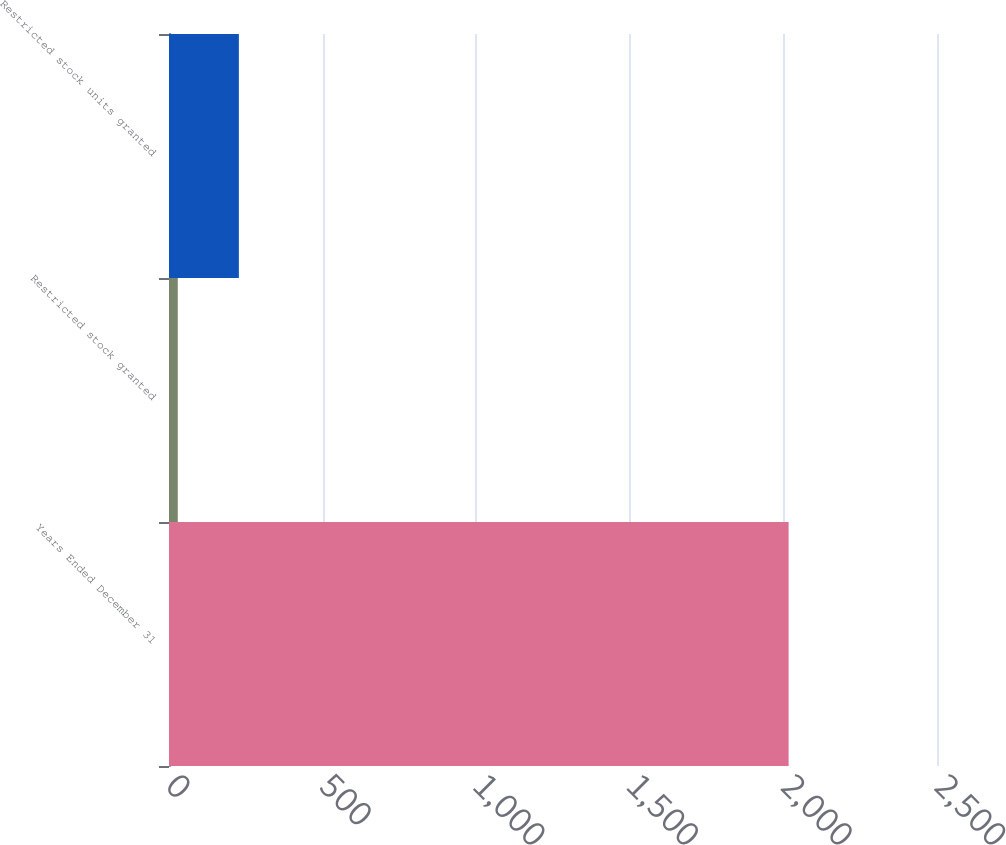Convert chart. <chart><loc_0><loc_0><loc_500><loc_500><bar_chart><fcel>Years Ended December 31<fcel>Restricted stock granted<fcel>Restricted stock units granted<nl><fcel>2017<fcel>28.61<fcel>227.45<nl></chart> 